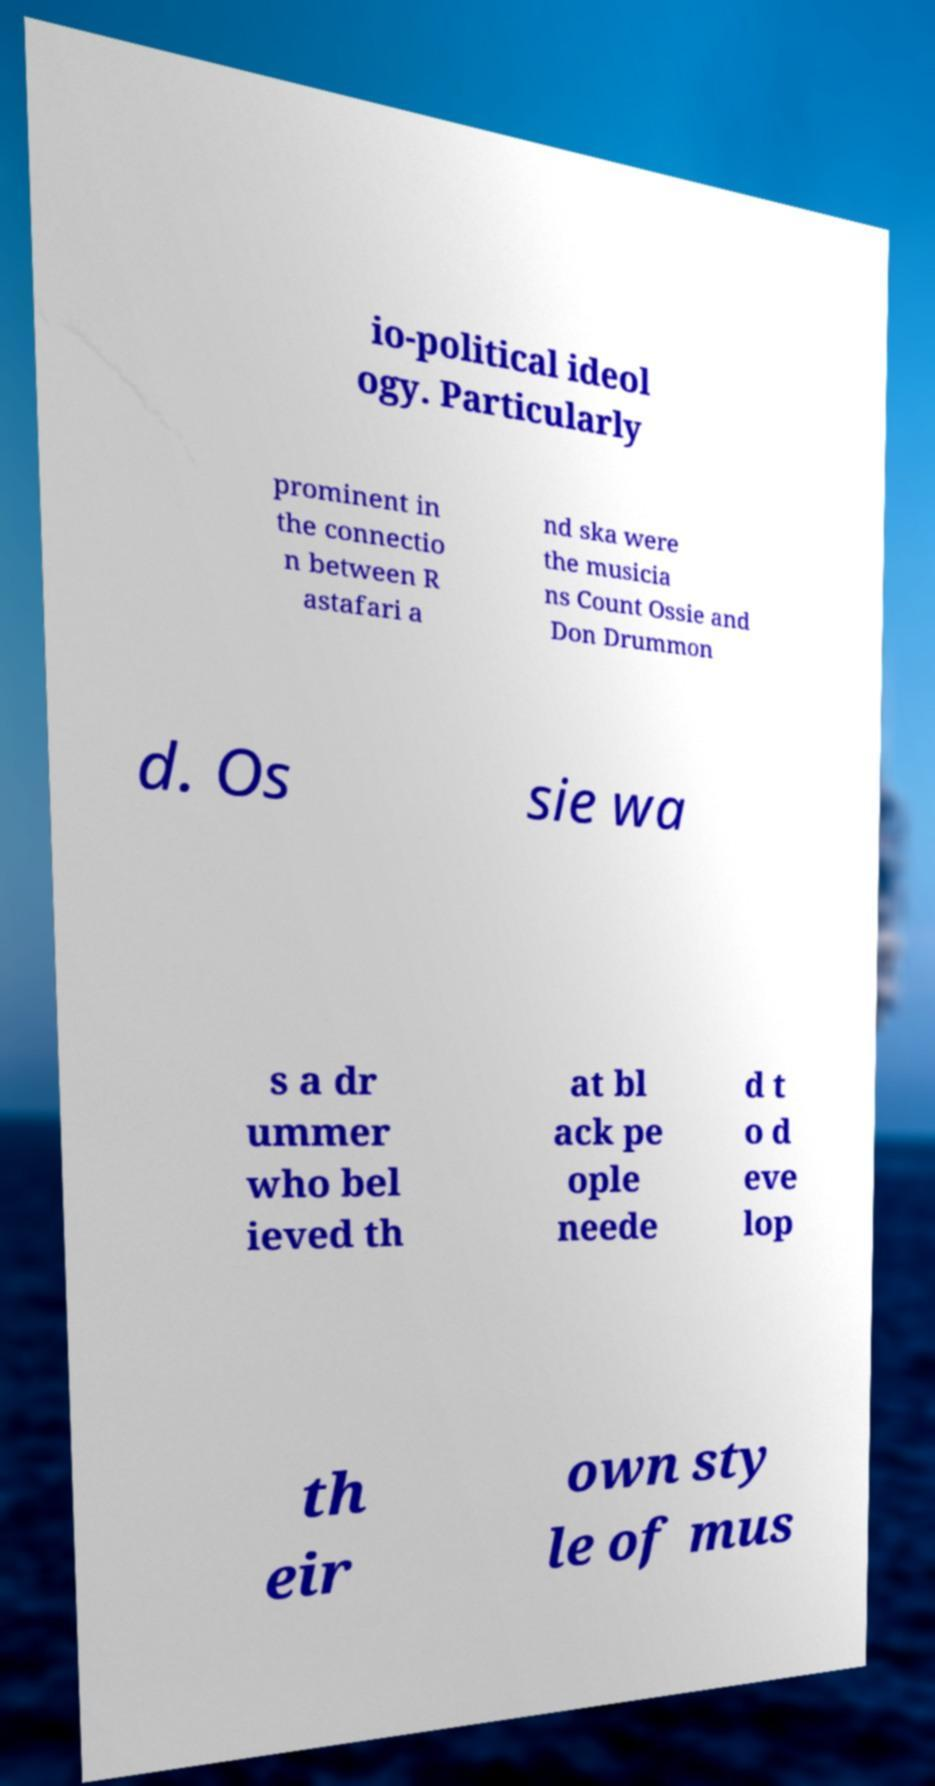Please identify and transcribe the text found in this image. io-political ideol ogy. Particularly prominent in the connectio n between R astafari a nd ska were the musicia ns Count Ossie and Don Drummon d. Os sie wa s a dr ummer who bel ieved th at bl ack pe ople neede d t o d eve lop th eir own sty le of mus 